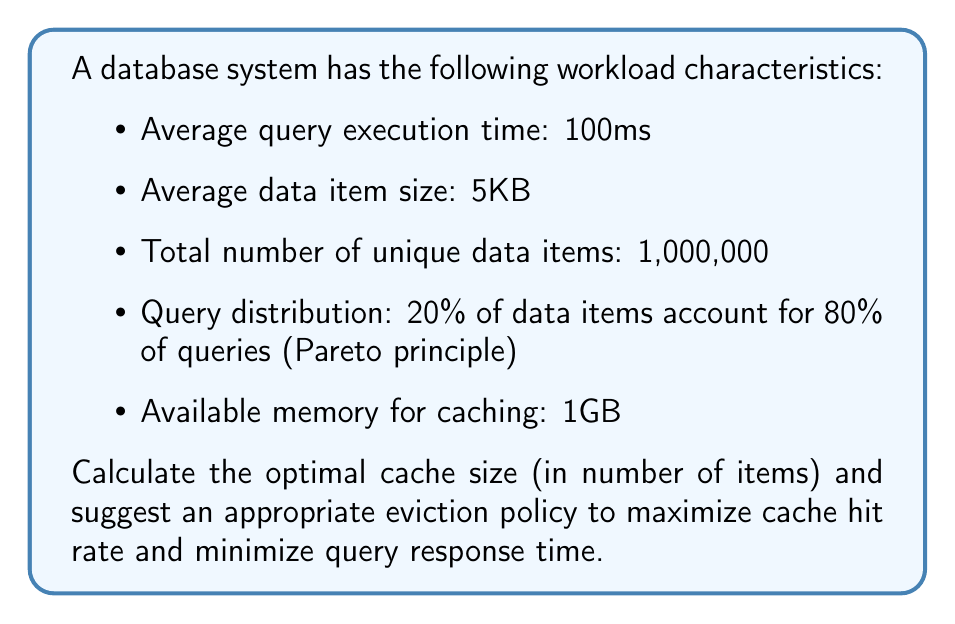Teach me how to tackle this problem. To solve this problem, we'll follow these steps:

1. Calculate the maximum number of items that can fit in the cache:
   $$\text{Max items} = \frac{\text{Available memory}}{\text{Average item size}}$$
   $$\text{Max items} = \frac{1\text{GB}}{5\text{KB}} = \frac{1,000,000\text{KB}}{5\text{KB}} = 200,000 \text{ items}$$

2. Consider the Pareto principle (80-20 rule):
   20% of data items account for 80% of queries, so we should prioritize caching these items.
   $$\text{High-frequency items} = 20\% \times 1,000,000 = 200,000 \text{ items}$$

3. Optimal cache size:
   The optimal cache size should be large enough to store all high-frequency items. In this case, it matches the maximum cache size.

4. Eviction policy:
   Given the skewed query distribution, a Least Frequently Used (LFU) eviction policy would be most appropriate. LFU keeps track of how often each item is accessed and evicts the least frequently used items when the cache is full.

5. Expected benefits:
   - Cache hit rate: Approximately 80% (since we can cache all high-frequency items)
   - Query response time improvement:
     $$\text{Average response time} = 0.8 \times 0\text{ms} + 0.2 \times 100\text{ms} = 20\text{ms}$$
     This represents an 80% reduction in average query response time.
Answer: Optimal cache size: 200,000 items; Eviction policy: LFU (Least Frequently Used) 